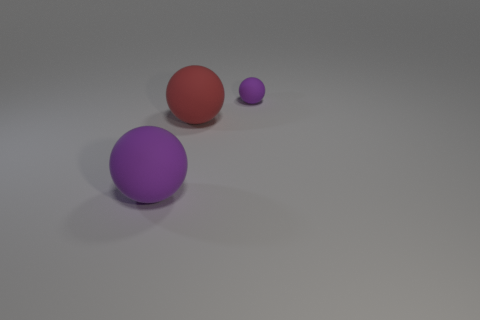What is the color of the big thing that is to the left of the big thing that is behind the purple sphere that is in front of the small purple ball?
Provide a succinct answer. Purple. How many brown objects are big matte objects or tiny spheres?
Your response must be concise. 0. How many big red cylinders are there?
Provide a succinct answer. 0. Is there any other thing that has the same shape as the big purple matte object?
Ensure brevity in your answer.  Yes. Does the purple sphere that is in front of the tiny rubber ball have the same material as the big ball behind the big purple matte object?
Your answer should be very brief. Yes. What material is the large purple ball?
Make the answer very short. Rubber. How many purple objects have the same material as the red thing?
Offer a very short reply. 2. What number of metal objects are either large gray cylinders or small purple spheres?
Your answer should be compact. 0. Is the shape of the purple thing that is in front of the big red matte ball the same as the purple object that is on the right side of the large red matte object?
Offer a very short reply. Yes. There is a thing that is in front of the tiny purple rubber thing and behind the big purple object; what color is it?
Your answer should be compact. Red. 